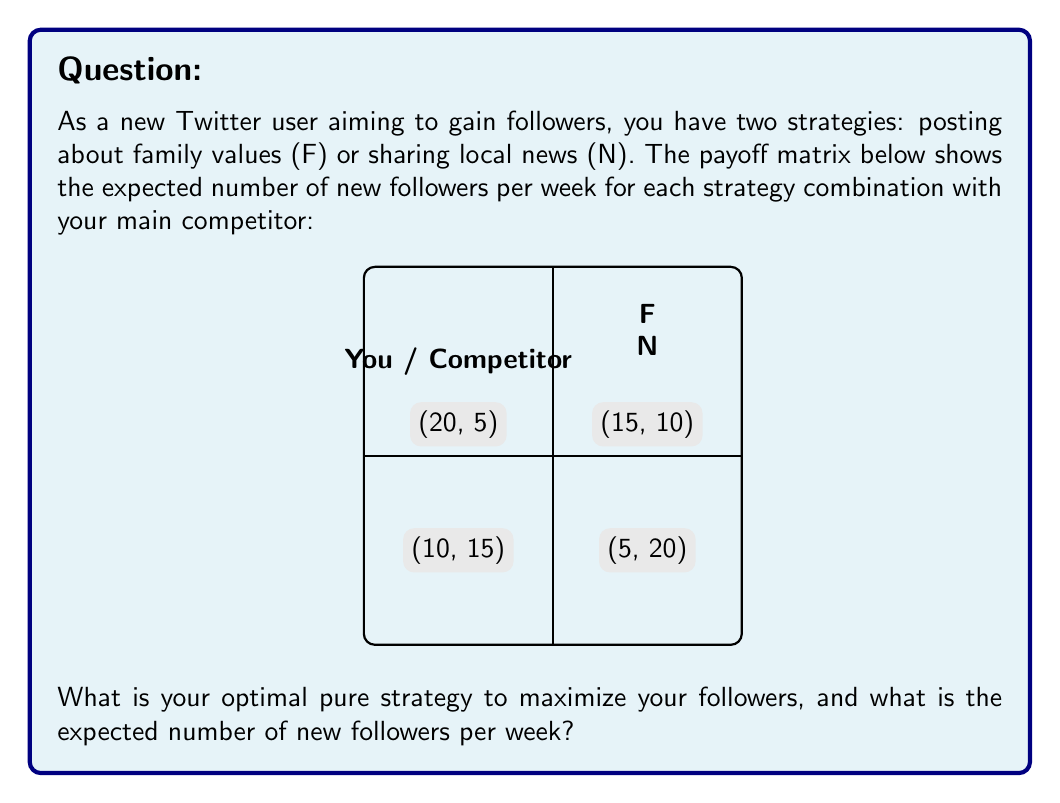Provide a solution to this math problem. To solve this game theory problem, we'll use the concept of dominant strategies:

1. First, compare your payoffs for each strategy:
   - When your competitor chooses F:
     F gives you 15, N gives you 5
   - When your competitor chooses N:
     F gives you 20, N gives you 10

2. We can see that F always gives you a higher payoff regardless of what your competitor does. This means F is your dominant strategy.

3. The expected number of new followers per week depends on what your competitor chooses:
   - If they choose F, you'll get 15 new followers
   - If they choose N, you'll get 20 new followers

4. Since we don't know what strategy your competitor will choose, we can't determine the exact number of new followers. However, we know it will be either 15 or 20.

5. In game theory, when we have a dominant strategy, it's always optimal to choose it regardless of what the other player does.

Therefore, your optimal pure strategy is to always choose F (posting about family values), which will result in either 15 or 20 new followers per week.
Answer: Strategy F; 15-20 followers/week 